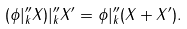Convert formula to latex. <formula><loc_0><loc_0><loc_500><loc_500>( \phi | ^ { \prime \prime } _ { k } X ) | ^ { \prime \prime } _ { k } X ^ { \prime } = \phi | ^ { \prime \prime } _ { k } ( X + X ^ { \prime } ) .</formula> 